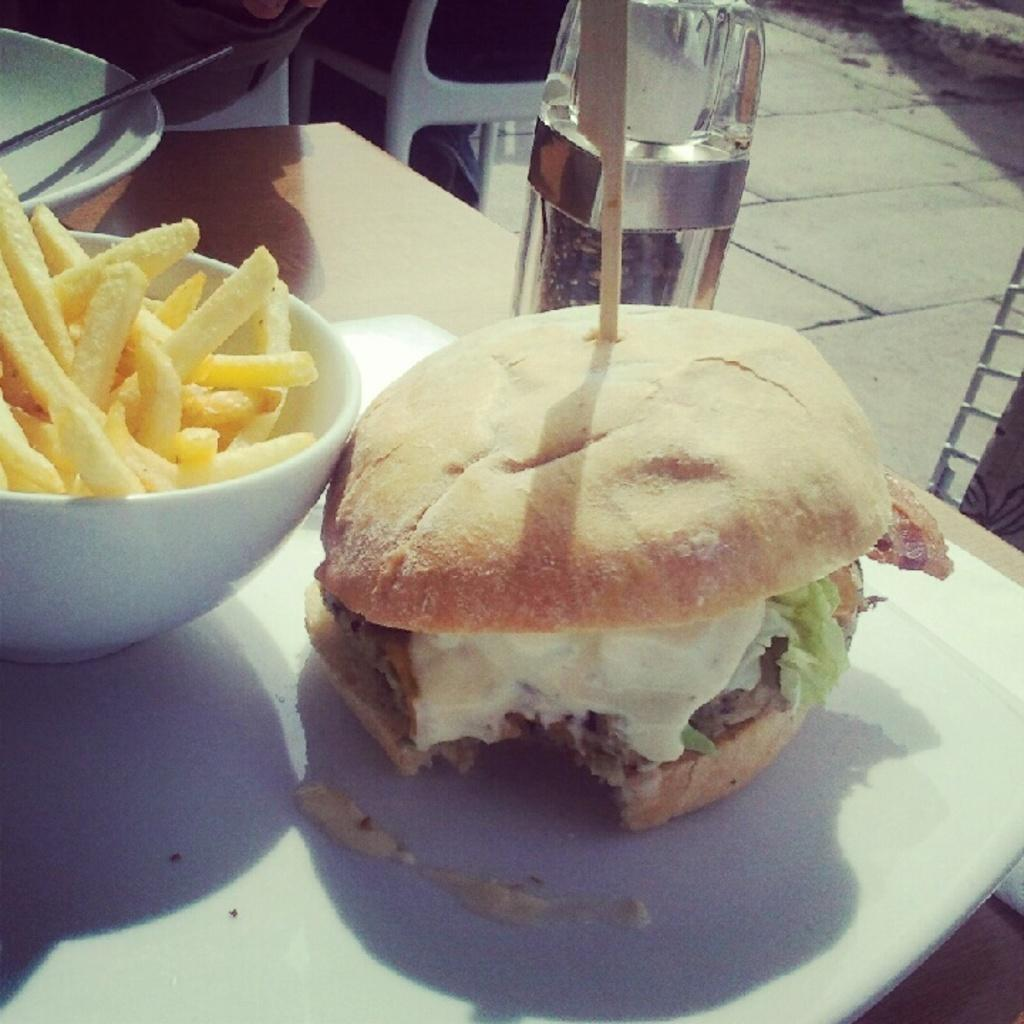What type of food is the main subject in the image? There is a burger in the image. What other food item is present in the image? There are french fries in the image. How are the burger and french fries arranged in the image? The burger and french fries are in a bowl. What is the surface on which the bowl is placed? The bowl is placed on a wooden table top. What color is the pencil used to draw on the burger in the image? There is no pencil or drawing present on the burger in the image. 